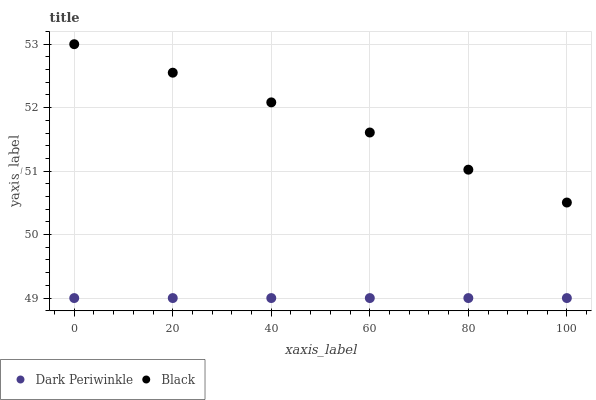Does Dark Periwinkle have the minimum area under the curve?
Answer yes or no. Yes. Does Black have the maximum area under the curve?
Answer yes or no. Yes. Does Dark Periwinkle have the maximum area under the curve?
Answer yes or no. No. Is Dark Periwinkle the smoothest?
Answer yes or no. Yes. Is Black the roughest?
Answer yes or no. Yes. Is Dark Periwinkle the roughest?
Answer yes or no. No. Does Dark Periwinkle have the lowest value?
Answer yes or no. Yes. Does Black have the highest value?
Answer yes or no. Yes. Does Dark Periwinkle have the highest value?
Answer yes or no. No. Is Dark Periwinkle less than Black?
Answer yes or no. Yes. Is Black greater than Dark Periwinkle?
Answer yes or no. Yes. Does Dark Periwinkle intersect Black?
Answer yes or no. No. 